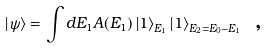<formula> <loc_0><loc_0><loc_500><loc_500>\left | \psi \right \rangle = \int d E _ { 1 } A ( E _ { 1 } ) \left | 1 \right \rangle _ { E _ { 1 } } \left | 1 \right \rangle _ { E _ { 2 } = E _ { 0 } - E _ { 1 } } \text { ,}</formula> 